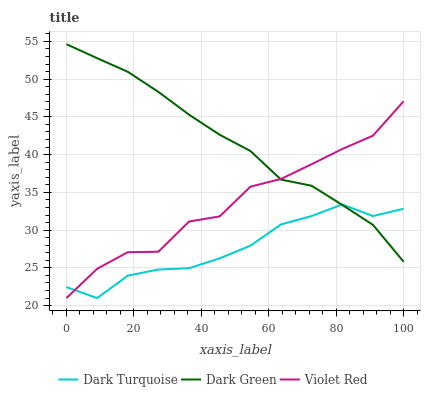Does Violet Red have the minimum area under the curve?
Answer yes or no. No. Does Violet Red have the maximum area under the curve?
Answer yes or no. No. Is Violet Red the smoothest?
Answer yes or no. No. Is Dark Green the roughest?
Answer yes or no. No. Does Dark Green have the lowest value?
Answer yes or no. No. Does Violet Red have the highest value?
Answer yes or no. No. 